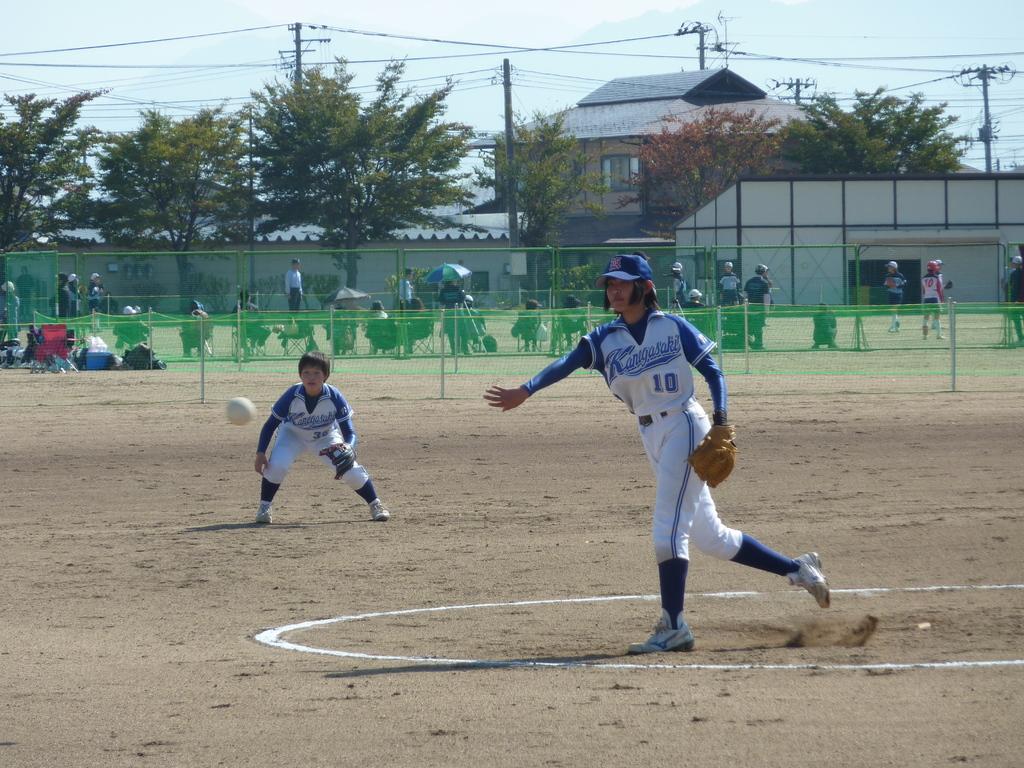What is the number on the pitcher's shirt?
Provide a succinct answer. 10. 